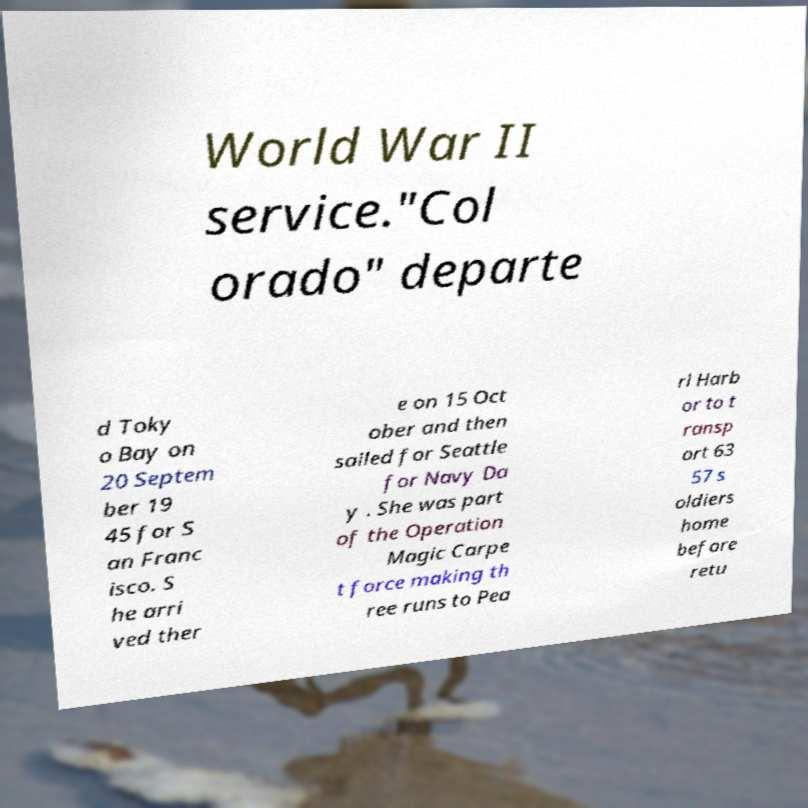Could you assist in decoding the text presented in this image and type it out clearly? World War II service."Col orado" departe d Toky o Bay on 20 Septem ber 19 45 for S an Franc isco. S he arri ved ther e on 15 Oct ober and then sailed for Seattle for Navy Da y . She was part of the Operation Magic Carpe t force making th ree runs to Pea rl Harb or to t ransp ort 63 57 s oldiers home before retu 